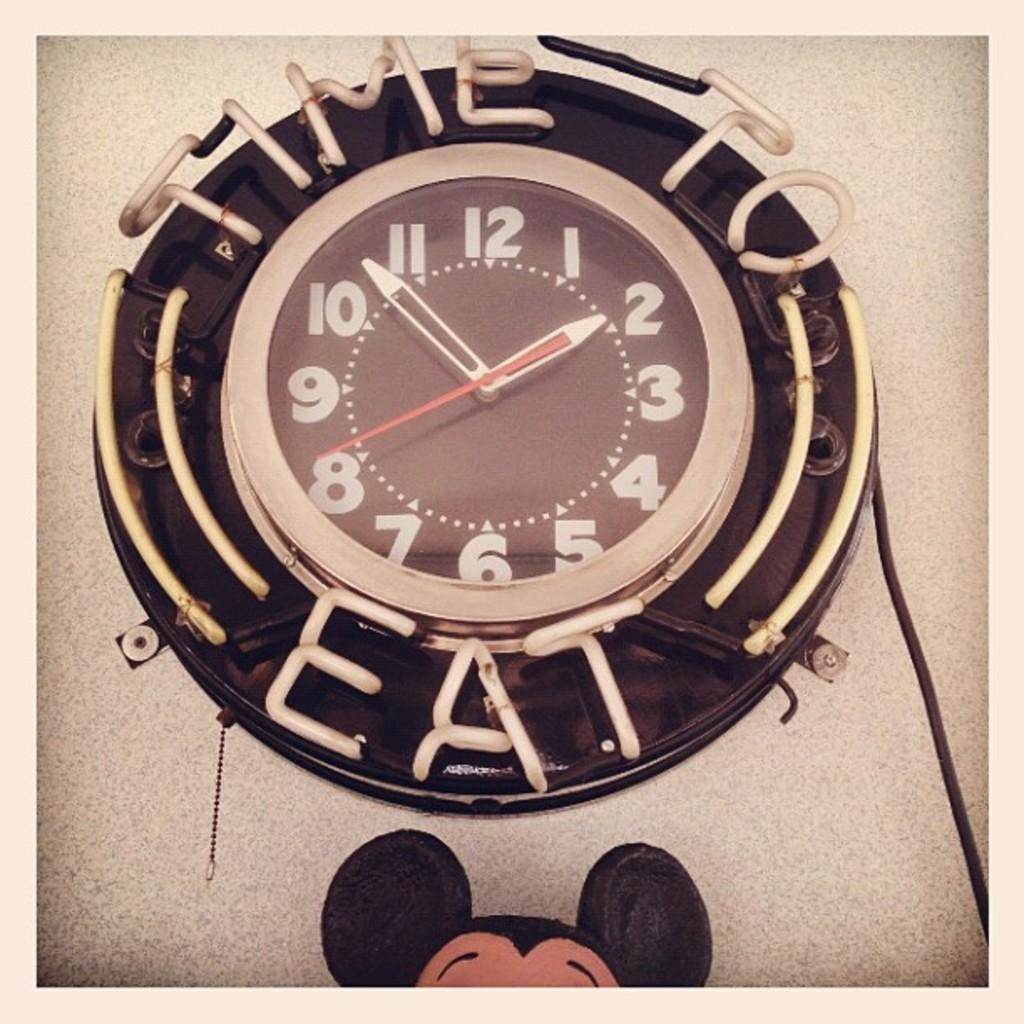<image>
Present a compact description of the photo's key features. a clock above mickey ears that says TIME TO EAT 